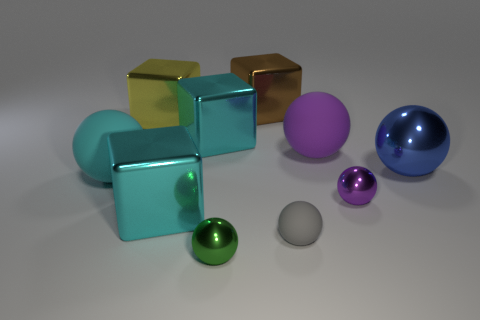Subtract all blue spheres. How many cyan cubes are left? 2 Subtract all large brown metal cubes. How many cubes are left? 3 Subtract all green balls. How many balls are left? 5 Subtract 1 blocks. How many blocks are left? 3 Subtract all purple blocks. Subtract all green cylinders. How many blocks are left? 4 Subtract 1 gray balls. How many objects are left? 9 Subtract all spheres. How many objects are left? 4 Subtract all large brown shiny cubes. Subtract all tiny rubber spheres. How many objects are left? 8 Add 3 small purple balls. How many small purple balls are left? 4 Add 9 small blue rubber cylinders. How many small blue rubber cylinders exist? 9 